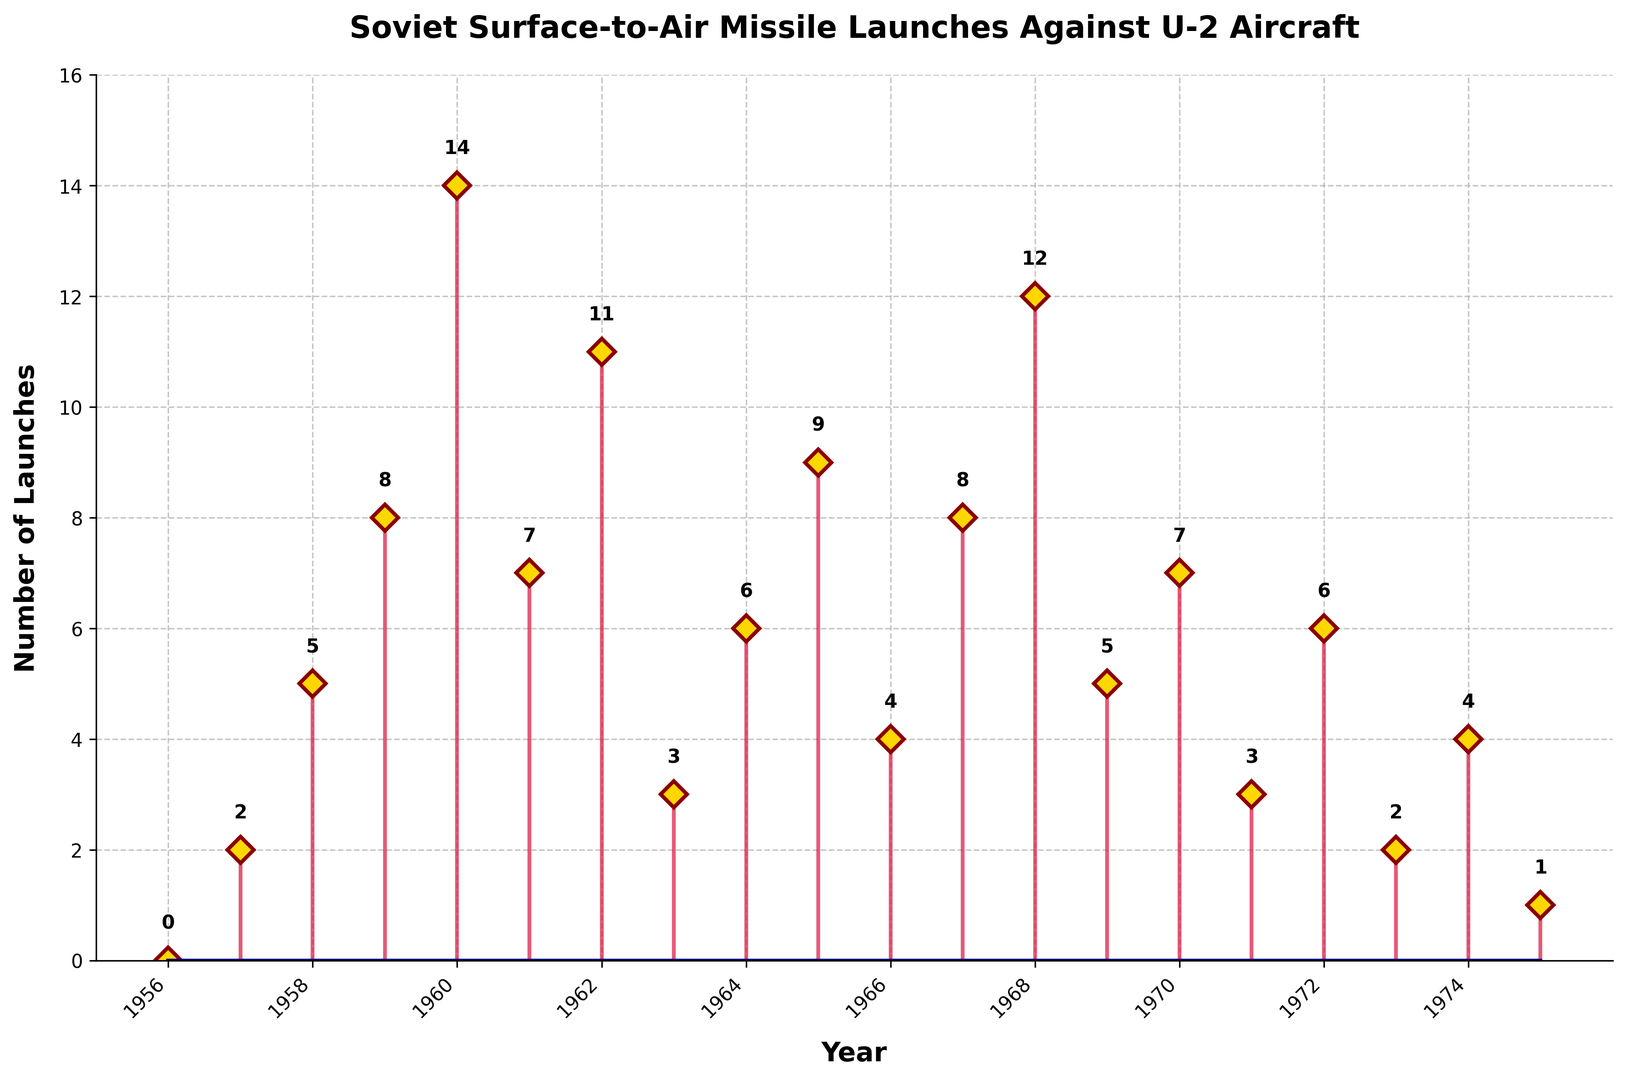When did the highest number of Soviet surface-to-air missile launches against U-2 aircraft occur? The highest number of launches is the tallest stem in the plot. The year corresponding to this peak is 1960.
Answer: 1960 What's the average number of Soviet surface-to-air missile launches per year from 1960 to 1965? To calculate the average, sum the launches from 1960 to 1965 and then divide by the number of years in that period: (14 + 7 + 11 + 3 + 6 + 9) / 6 = 50 / 6.
Answer: 8.33 Which year had fewer launches, 1958 or 1969? Compare the heights of the stems for the years 1958 and 1969. The number of launches in 1958 is 5, and in 1969, it's also 5.
Answer: Neither, both are equal What is the total number of launches recorded in the years 1957 and 1965 combined? Sum the number of launches for the years 1957 and 1965: 2 + 9.
Answer: 11 How does the number of launches in 1967 compare to that in 1970? Compare the height of the stems for 1967 and 1970. The number of launches in 1967 is 8, and in 1970, it's 7.
Answer: 1967 had more Is the trend from 1956 to 1960 increasing or decreasing? Check whether the number of launches increases or decreases each year from 1956 to 1960.It is increasing from 0 to 14 over these years.
Answer: Increasing What is the median number of launches over the whole period? List all the launch counts and find the median value. The sorted launch counts are 0, 1, 2, 2, 3, 3, 4, 4, 5, 5, 6, 6, 7, 7, 8, 8, 9, 11, 12, 14. There are 20 values, so the median is the average of the 10th and 11th values: (5 + 6) / 2.
Answer: 5.5 What's the mode of the Soviet surface-to-air missile launches data? Identify the number that appears most frequently in the launch counts. Both 3 and 6 appear twice each.
Answer: 3 and 6 What is the number of launches in the final year shown on the plot? Look at the last stem in the plot, which is for the year 1975. The corresponding count is 1.
Answer: 1 